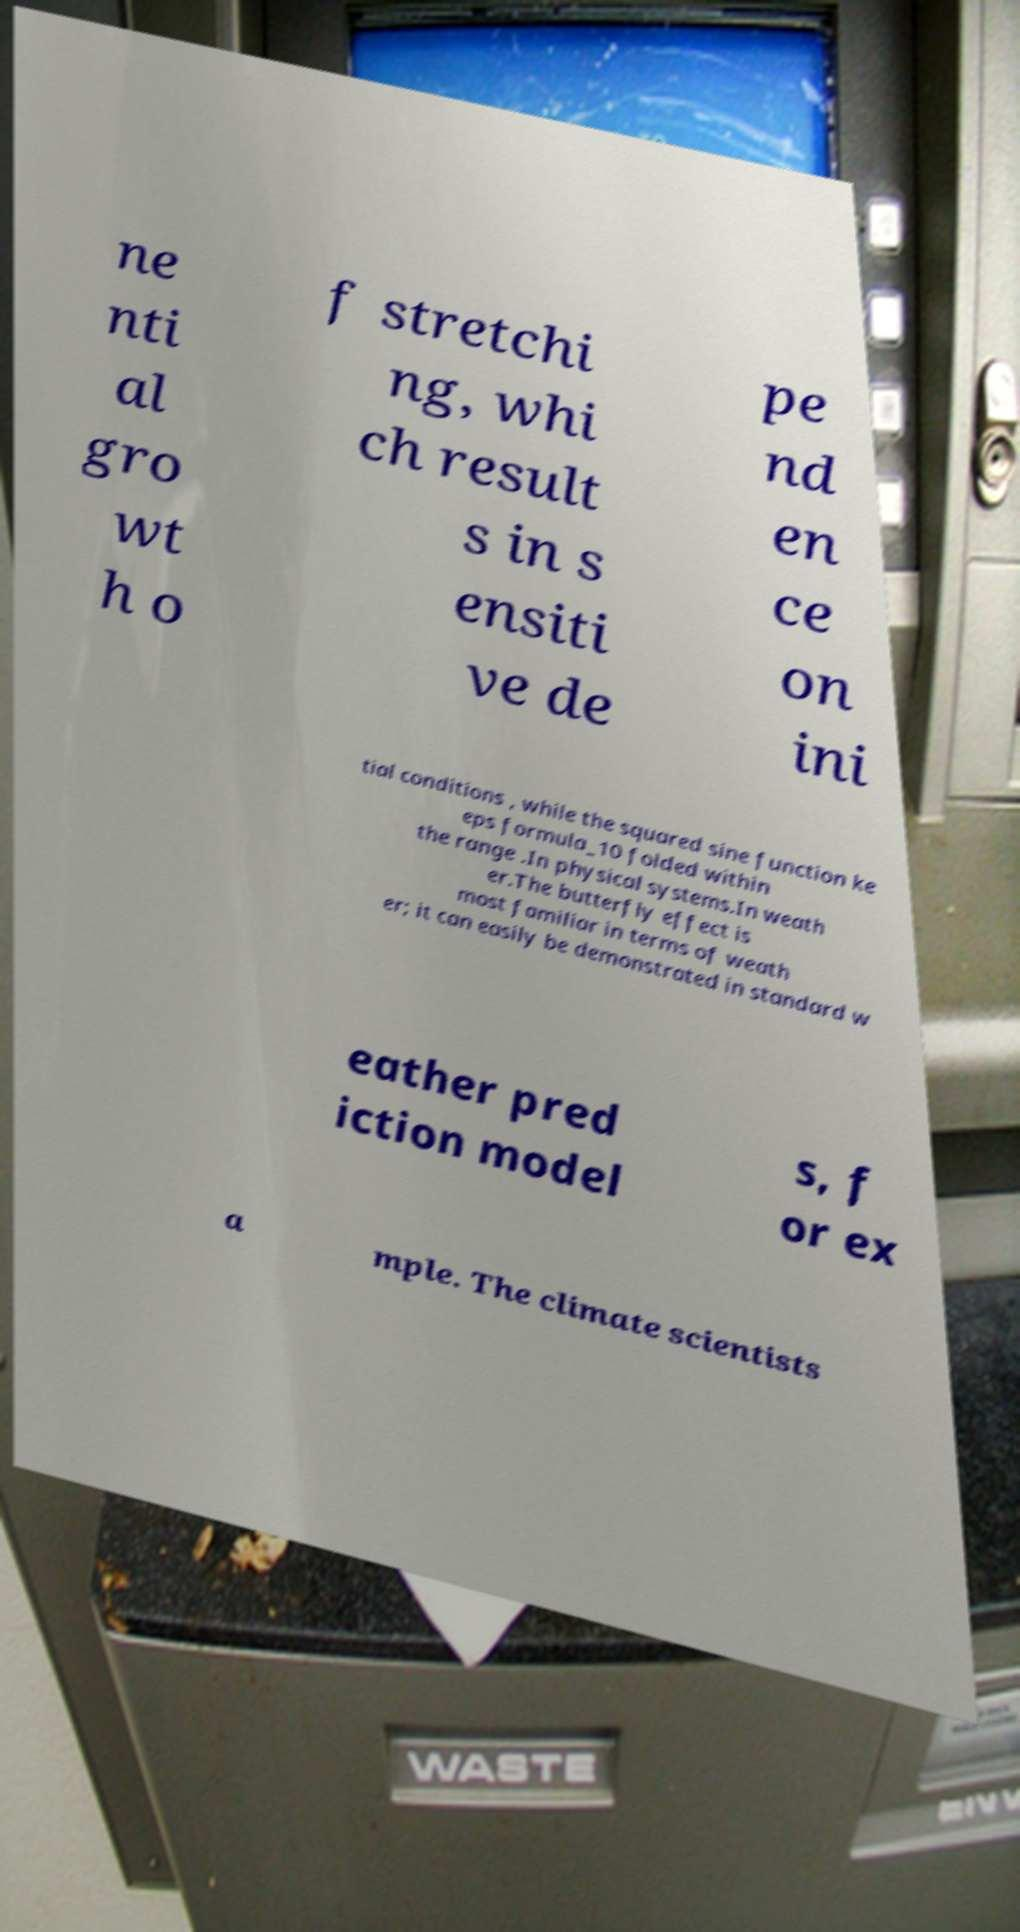I need the written content from this picture converted into text. Can you do that? ne nti al gro wt h o f stretchi ng, whi ch result s in s ensiti ve de pe nd en ce on ini tial conditions , while the squared sine function ke eps formula_10 folded within the range .In physical systems.In weath er.The butterfly effect is most familiar in terms of weath er; it can easily be demonstrated in standard w eather pred iction model s, f or ex a mple. The climate scientists 